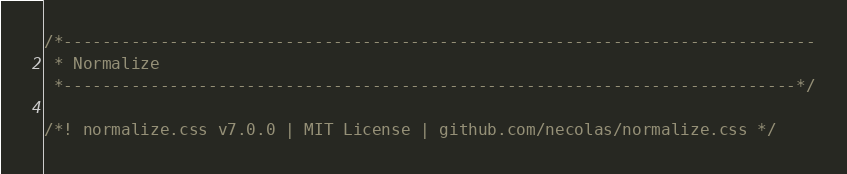Convert code to text. <code><loc_0><loc_0><loc_500><loc_500><_CSS_>/*------------------------------------------------------------------------------
 * Normalize
 *----------------------------------------------------------------------------*/

/*! normalize.css v7.0.0 | MIT License | github.com/necolas/normalize.css */</code> 